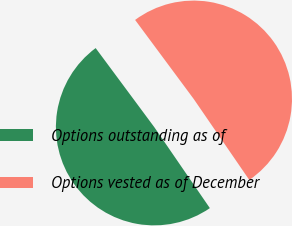Convert chart. <chart><loc_0><loc_0><loc_500><loc_500><pie_chart><fcel>Options outstanding as of<fcel>Options vested as of December<nl><fcel>49.42%<fcel>50.58%<nl></chart> 